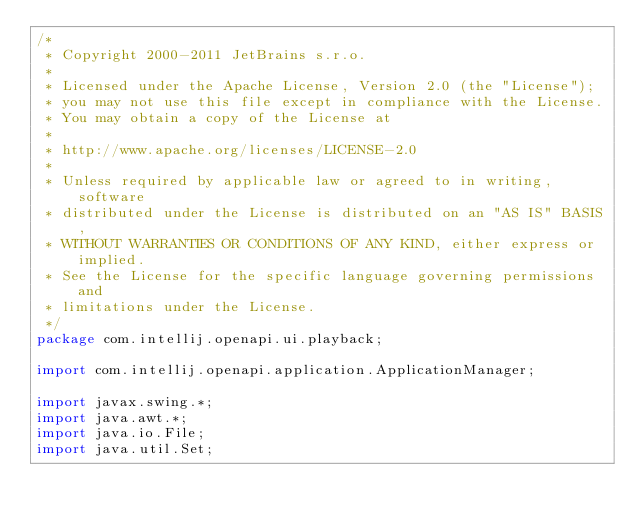<code> <loc_0><loc_0><loc_500><loc_500><_Java_>/*
 * Copyright 2000-2011 JetBrains s.r.o.
 *
 * Licensed under the Apache License, Version 2.0 (the "License");
 * you may not use this file except in compliance with the License.
 * You may obtain a copy of the License at
 *
 * http://www.apache.org/licenses/LICENSE-2.0
 *
 * Unless required by applicable law or agreed to in writing, software
 * distributed under the License is distributed on an "AS IS" BASIS,
 * WITHOUT WARRANTIES OR CONDITIONS OF ANY KIND, either express or implied.
 * See the License for the specific language governing permissions and
 * limitations under the License.
 */
package com.intellij.openapi.ui.playback;

import com.intellij.openapi.application.ApplicationManager;

import javax.swing.*;
import java.awt.*;
import java.io.File;
import java.util.Set;
</code> 